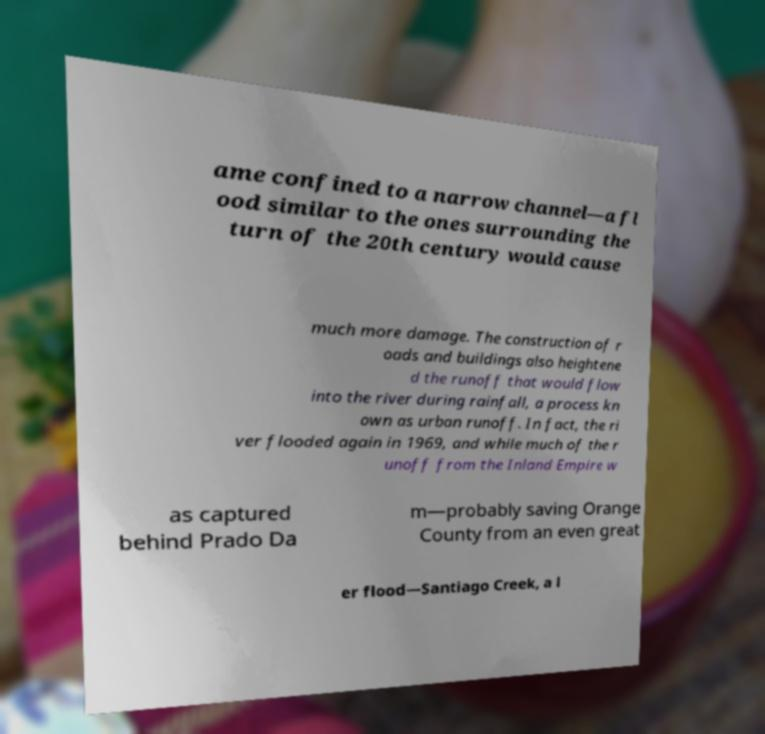Can you read and provide the text displayed in the image?This photo seems to have some interesting text. Can you extract and type it out for me? ame confined to a narrow channel—a fl ood similar to the ones surrounding the turn of the 20th century would cause much more damage. The construction of r oads and buildings also heightene d the runoff that would flow into the river during rainfall, a process kn own as urban runoff. In fact, the ri ver flooded again in 1969, and while much of the r unoff from the Inland Empire w as captured behind Prado Da m—probably saving Orange County from an even great er flood—Santiago Creek, a l 